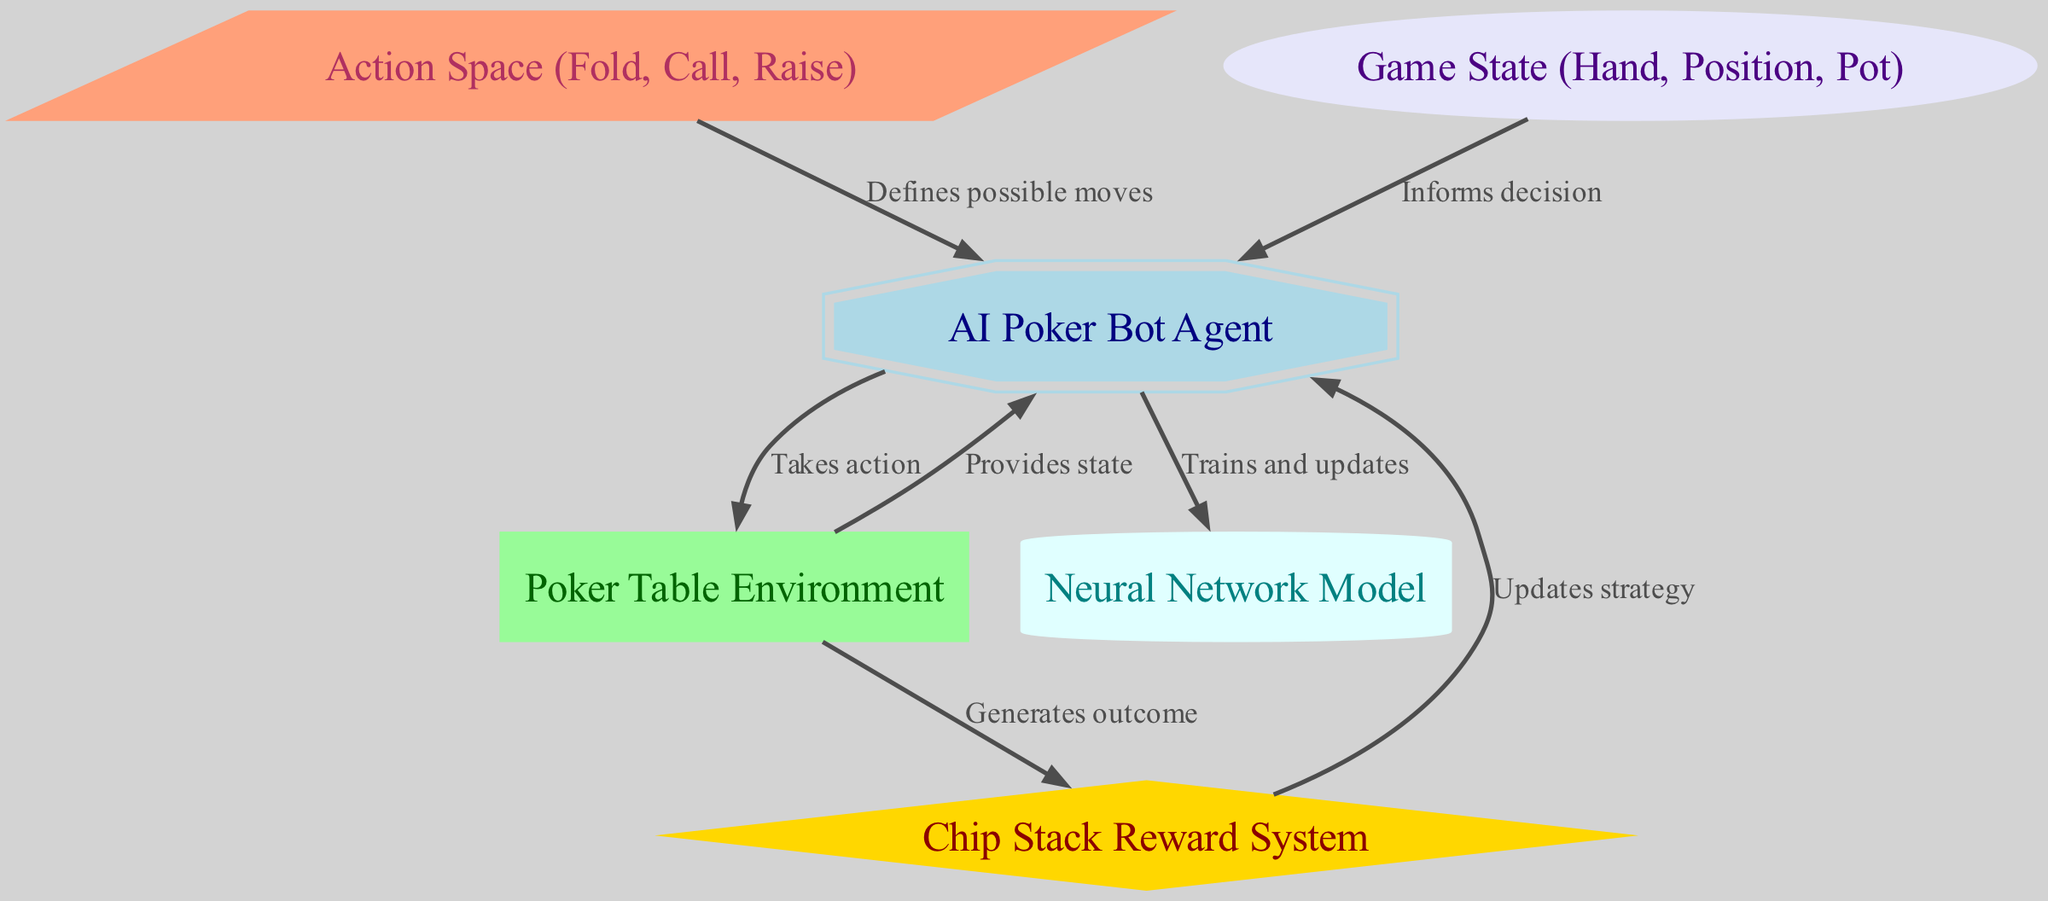What are the three actions defined in the action space? The action space node is linked to the agent and defines possible moves, which, according to the diagram, are "Fold," "Call," and "Raise."
Answer: Fold, Call, Raise How many nodes are depicted in the diagram? The diagram has six nodes: AI Poker Bot Agent, Poker Table Environment, Chip Stack Reward System, Action Space, Game State, and Neural Network Model. Counting them gives a total of six.
Answer: Six What does the reward system provide to the agent? The reward system updates the agent's strategy based on the outcomes generated from the environment, which is depicted in the diagram.
Answer: Updates strategy Which node informs the agent's decision-making? The Game State node provides essential information about the current game conditions such as hand, position, and pot, which informs the agent's decision-making process.
Answer: Game State What is the shape of the AI Poker Bot Agent node in the diagram? The AI Poker Bot Agent is represented by a double octagon shape in the diagram, as specified in the node styles.
Answer: Double octagon What types of edges are present in the diagram? The edges depict relationships between nodes showing actions, updates, and information flow. Each edge has a label indicating its purpose, but they all connect various components of the reinforcement learning framework.
Answer: Actions, updates, information What is the color of the Poker Table Environment node? The Poker Table Environment node is filled with a pale green color, distinguishing it from other nodes in the diagram.
Answer: Pale green Which node does the agent use to train and update? The agent directly interacts with the Neural Network Model node to carry out training and updates, as represented by the directed edge connecting both nodes.
Answer: Neural Network Model What relationship does the environment have with the reward system? The Poker Table Environment generates outcomes that provide necessary input to the Chip Stack Reward System, depicting a direct relationship.
Answer: Generates outcome 